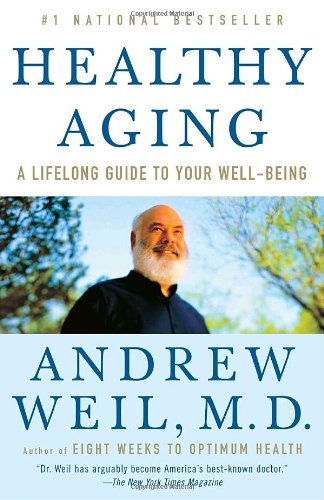What critical message does the book convey about aging? The book emphasizes a proactive approach to aging, advocating for a lifestyle that integrates physical health, diet, and mental wellness to ensure a balanced and fulfilling older age. 